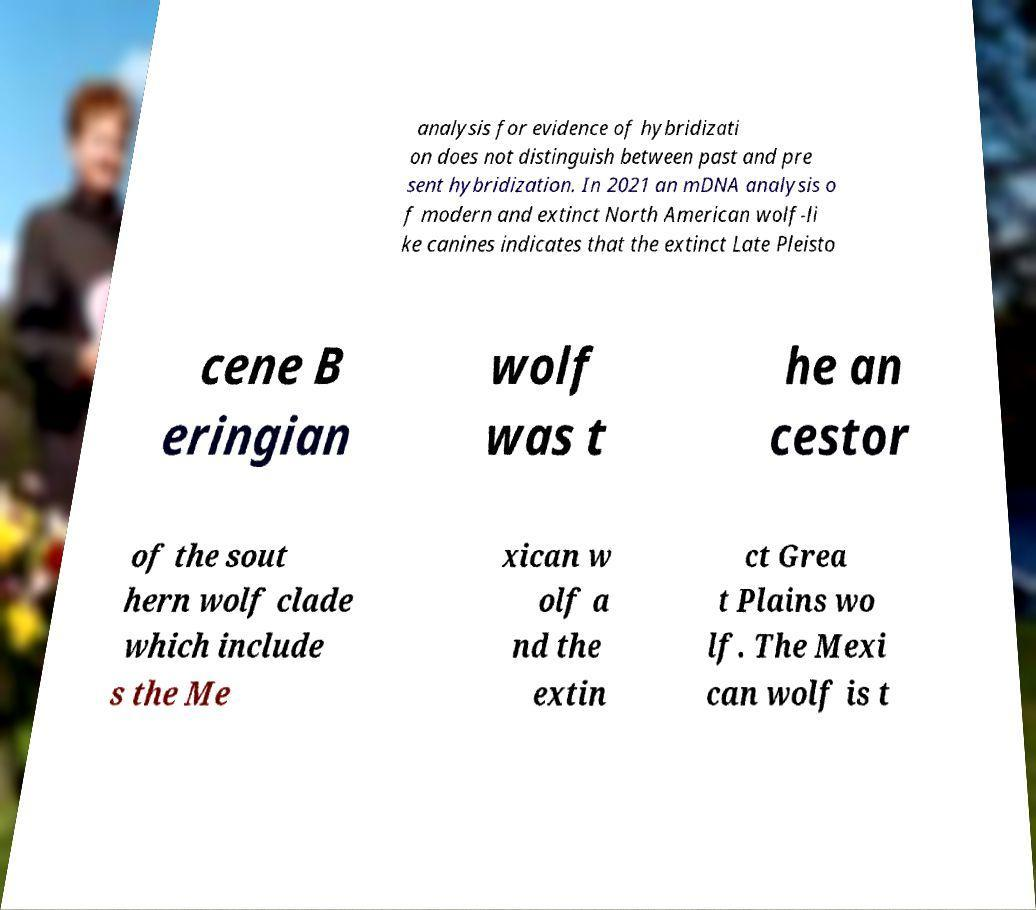Can you read and provide the text displayed in the image?This photo seems to have some interesting text. Can you extract and type it out for me? analysis for evidence of hybridizati on does not distinguish between past and pre sent hybridization. In 2021 an mDNA analysis o f modern and extinct North American wolf-li ke canines indicates that the extinct Late Pleisto cene B eringian wolf was t he an cestor of the sout hern wolf clade which include s the Me xican w olf a nd the extin ct Grea t Plains wo lf. The Mexi can wolf is t 